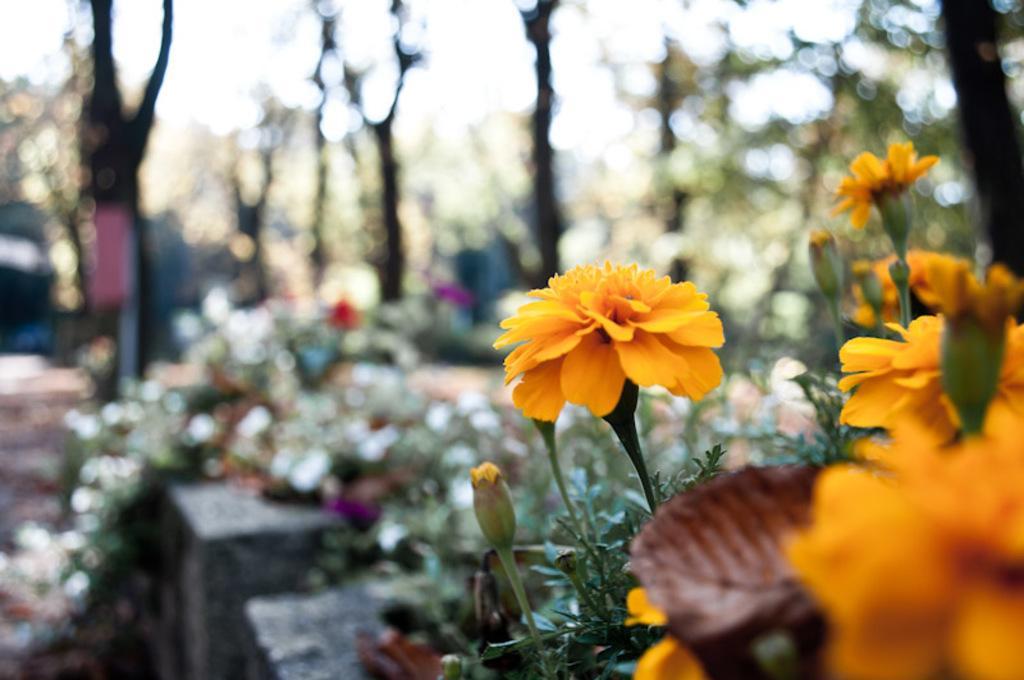In one or two sentences, can you explain what this image depicts? In this picture, we can see plants, flowers, and the blurred background. 